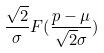<formula> <loc_0><loc_0><loc_500><loc_500>\frac { \sqrt { 2 } } { \sigma } F ( \frac { p - \mu } { \sqrt { 2 } \sigma } )</formula> 